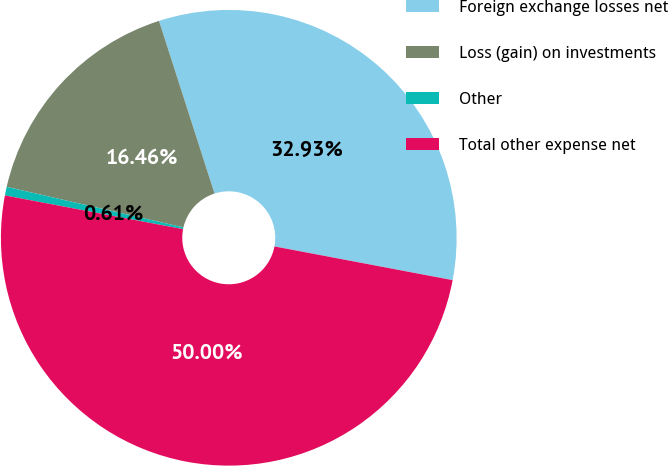<chart> <loc_0><loc_0><loc_500><loc_500><pie_chart><fcel>Foreign exchange losses net<fcel>Loss (gain) on investments<fcel>Other<fcel>Total other expense net<nl><fcel>32.93%<fcel>16.46%<fcel>0.61%<fcel>50.0%<nl></chart> 